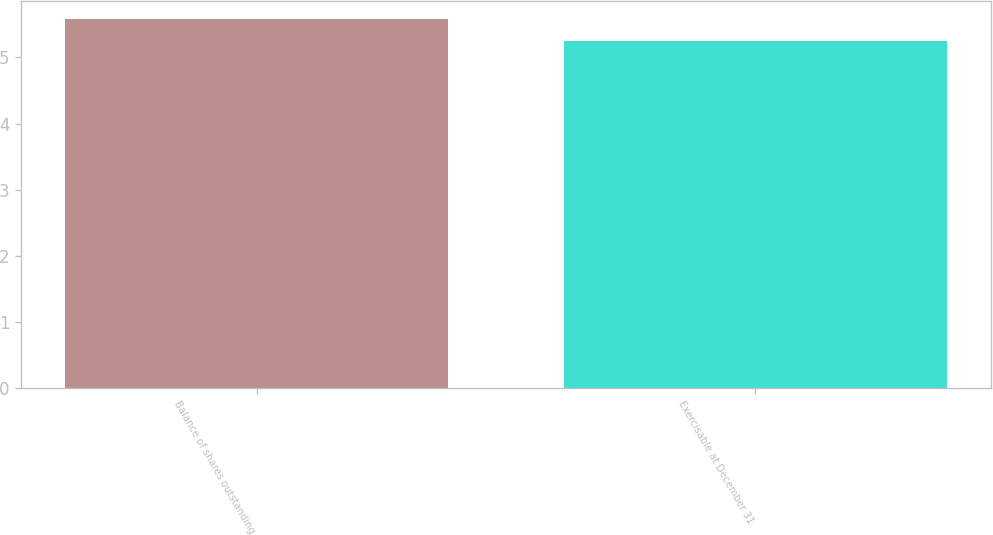<chart> <loc_0><loc_0><loc_500><loc_500><bar_chart><fcel>Balance of shares outstanding<fcel>Exercisable at December 31<nl><fcel>5.58<fcel>5.25<nl></chart> 